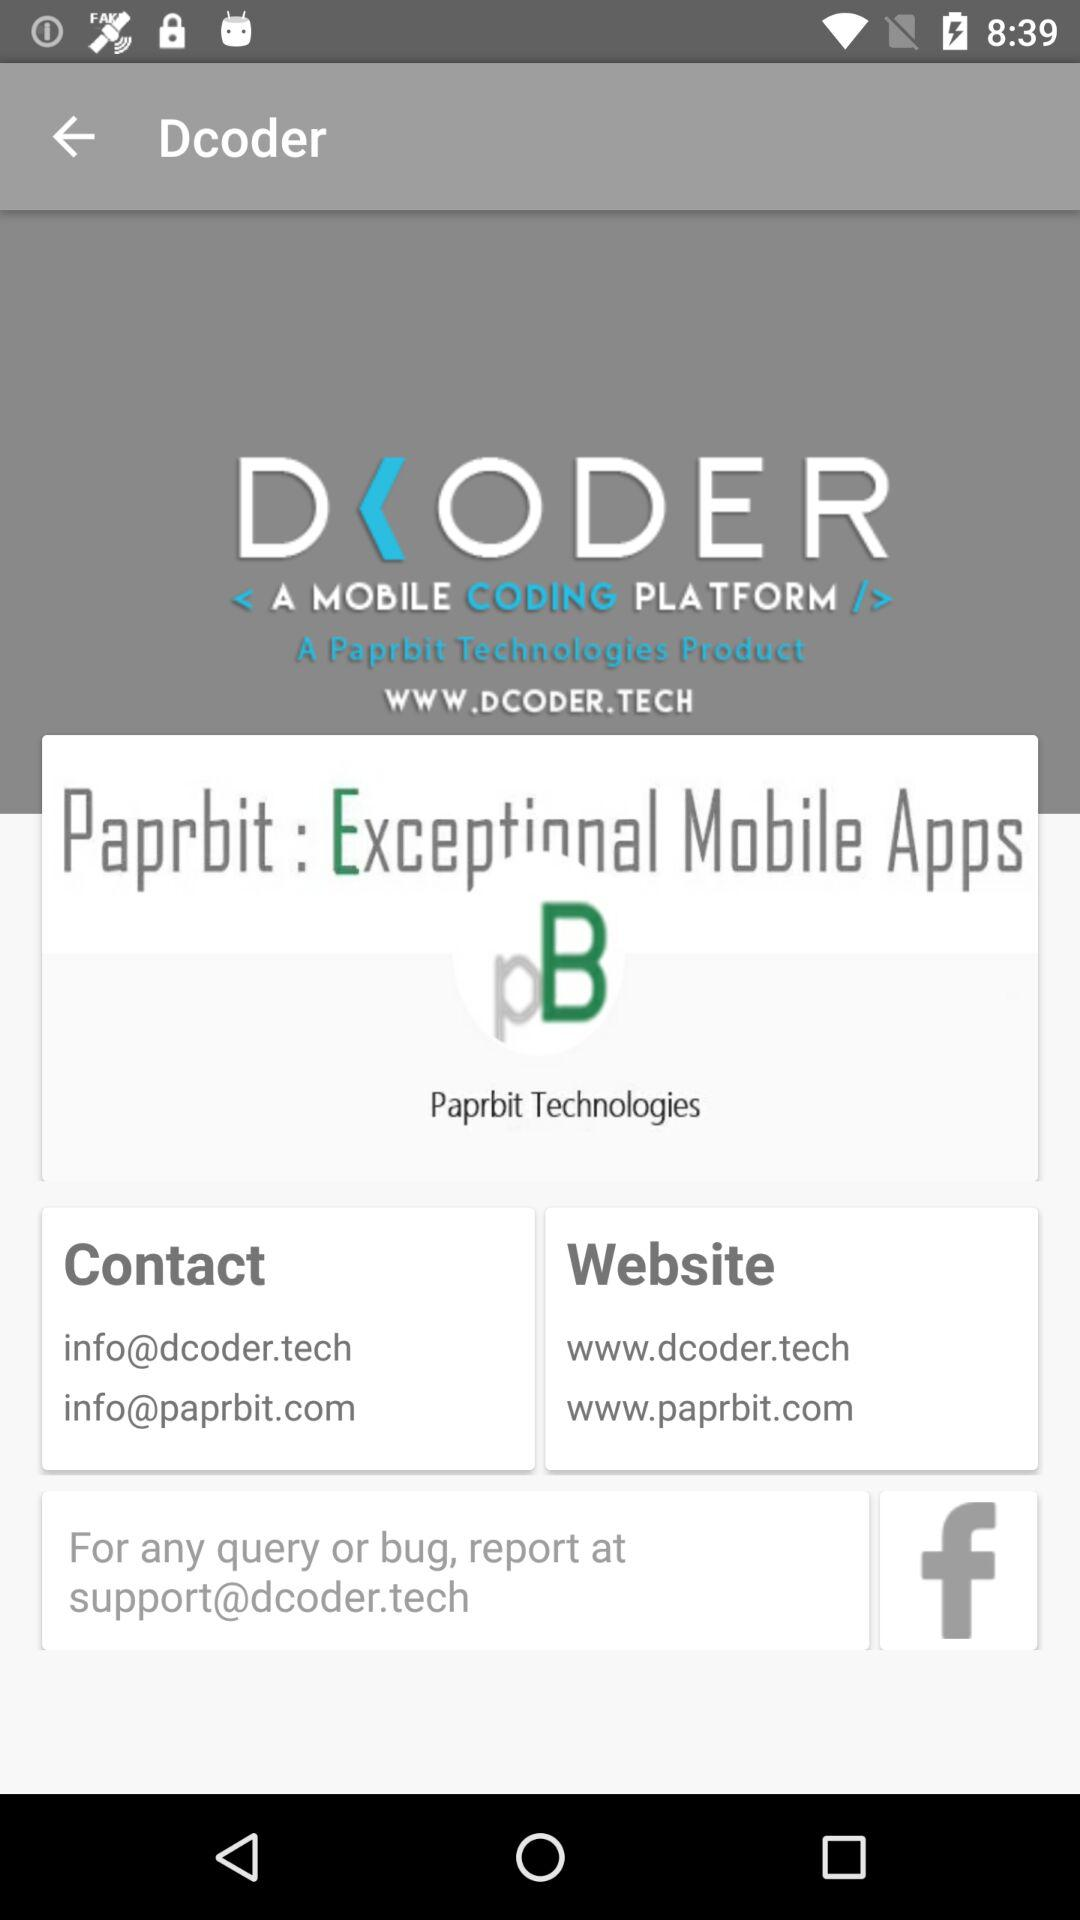What is the contact email address? The contact email addresses are info@dcoder.tech and info@paprbit.com. 